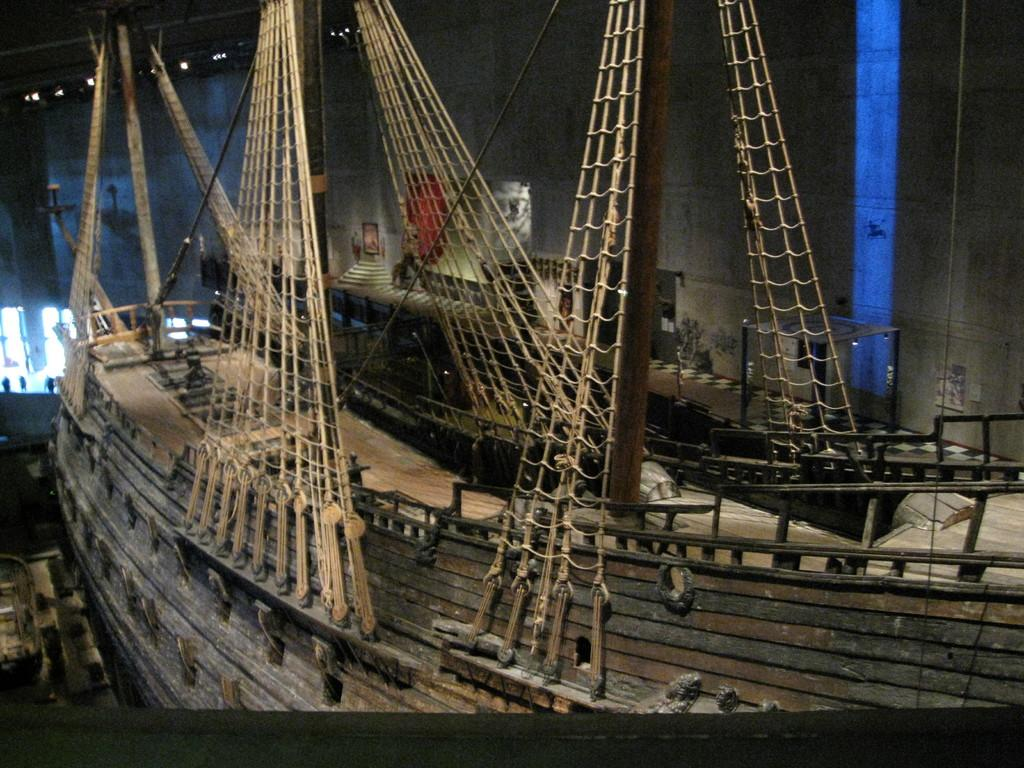What is the main subject of the image? The main subject of the image is a ship. What are some of the features or components of the ship? There are poles, ropes, steps, and lights visible in the image. Can you describe the background of the image? There is a wall visible in the background of the image. Are there any other objects or elements in the image besides the ship and its components? Yes, there are some unspecified objects in the image. What type of art can be seen on the ship's sails in the image? There is no art visible on the ship's sails in the image. What type of rice is being served in the image? There is no rice present in the image. 